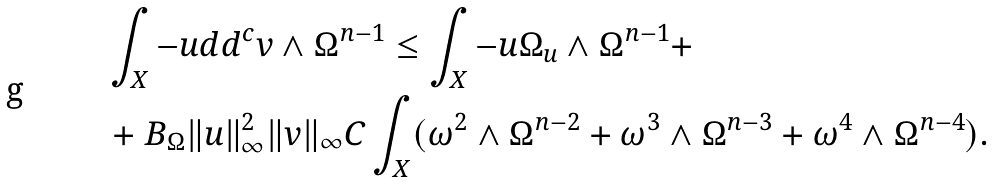Convert formula to latex. <formula><loc_0><loc_0><loc_500><loc_500>& \int _ { X } - u d d ^ { c } v \wedge \Omega ^ { n - 1 } \leq \int _ { X } - u \Omega _ { u } \wedge \Omega ^ { n - 1 } + \\ & + B _ { \Omega } \| u \| _ { \infty } ^ { 2 } \| v \| _ { \infty } C \int _ { X } ( \omega ^ { 2 } \wedge \Omega ^ { n - 2 } + \omega ^ { 3 } \wedge \Omega ^ { n - 3 } + \omega ^ { 4 } \wedge \Omega ^ { n - 4 } ) .</formula> 